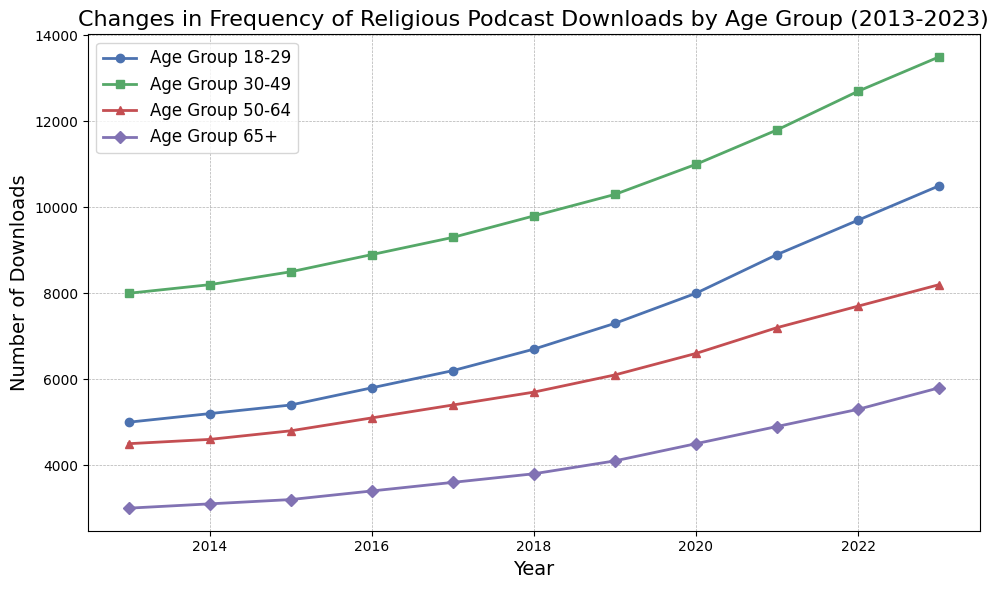What age group had the highest number of downloads in 2023? To determine the age group with the highest number of downloads in 2023, look at each value for the year 2023 and identify the largest number. Age Group 18-29 has 10500 downloads, Age Group 30-49 has 13500, Age Group 50-64 has 8200, and Age Group 65+ has 5800. Age Group 30-49 has the highest number at 13500.
Answer: Age Group 30-49 How did the number of downloads for Age Group 18-29 change from 2013 to 2023? To track the change for Age Group 18-29, subtract the value in 2013 (5000) from the value in 2023 (10500). The change is 10500 - 5000 = 5500.
Answer: 5500 Which age group exhibited the largest overall increase in downloads from 2013 to 2023? Compute the difference between the 2023 and 2013 values for each age group. Age Group 18-29: 10500 - 5000 = 5500, Age Group 30-49: 13500 - 8000 = 5500, Age Group 50-64: 8200 - 4500 = 3700, Age Group 65+: 5800 - 3000 = 2800. Both Age Group 18-29 and Age Group 30-49 show the largest increase of 5500.
Answer: Age Group 18-29 and Age Group 30-49 During which year did Age Group 50-64 first surpass 5000 downloads? Identify the first year where the number of downloads for Age Group 50-64 exceeded 5000. In 2016, the number was 5100, which is the first year beyond 5000.
Answer: 2016 Compare the number of downloads in 2017 for Age Group 18-29 and Age Group 65+. Which group had more downloads, and by how much? Look at the download numbers in 2017 for both age groups. Age Group 18-29 had 6200 downloads, and Age Group 65+ had 3600 downloads. The difference is 6200 - 3600 = 2600 more for Age Group 18-29.
Answer: Age Group 18-29, by 2600 What has been the average yearly increase in downloads for Age Group 30-49 over the decade? Calculate the total increase from 2013 to 2023 (13500 - 8000 = 5500). Then, divide this by the number of years (2023 - 2013 = 10). The average yearly increase is 5500 / 10 = 550.
Answer: 550 In which year did Age Group 65+ have an equal number of downloads to Age Group 30-49 in 2013? In 2013, Age Group 30-49 had 8000 downloads. Look for the year where Age Group 65+ also reached 8000. Age Group 65+ does not reach 8000 in any year from 2013 to 2023.
Answer: Never Which year had the highest overall number of downloads across all age groups? Add the number of downloads for all age groups each year. The highest total is in 2023: 10500 + 13500 + 8200 + 5800 = 38000.
Answer: 2023 